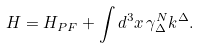<formula> <loc_0><loc_0><loc_500><loc_500>H = H _ { P F } + \int d ^ { 3 } x \, \gamma ^ { N } _ { \Delta } k ^ { \Delta } .</formula> 